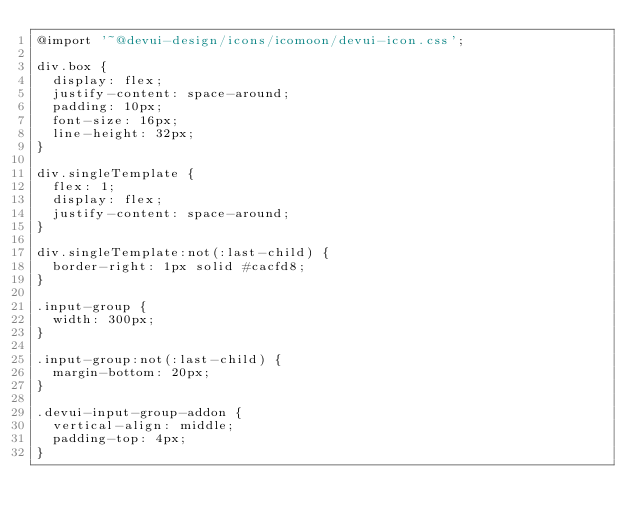<code> <loc_0><loc_0><loc_500><loc_500><_CSS_>@import '~@devui-design/icons/icomoon/devui-icon.css';

div.box {
  display: flex;
  justify-content: space-around;
  padding: 10px;
  font-size: 16px;
  line-height: 32px;
}

div.singleTemplate {
  flex: 1;
  display: flex;
  justify-content: space-around;
}

div.singleTemplate:not(:last-child) {
  border-right: 1px solid #cacfd8;
}

.input-group {
  width: 300px;
}

.input-group:not(:last-child) {
  margin-bottom: 20px;
}

.devui-input-group-addon {
  vertical-align: middle;
  padding-top: 4px;
}
</code> 